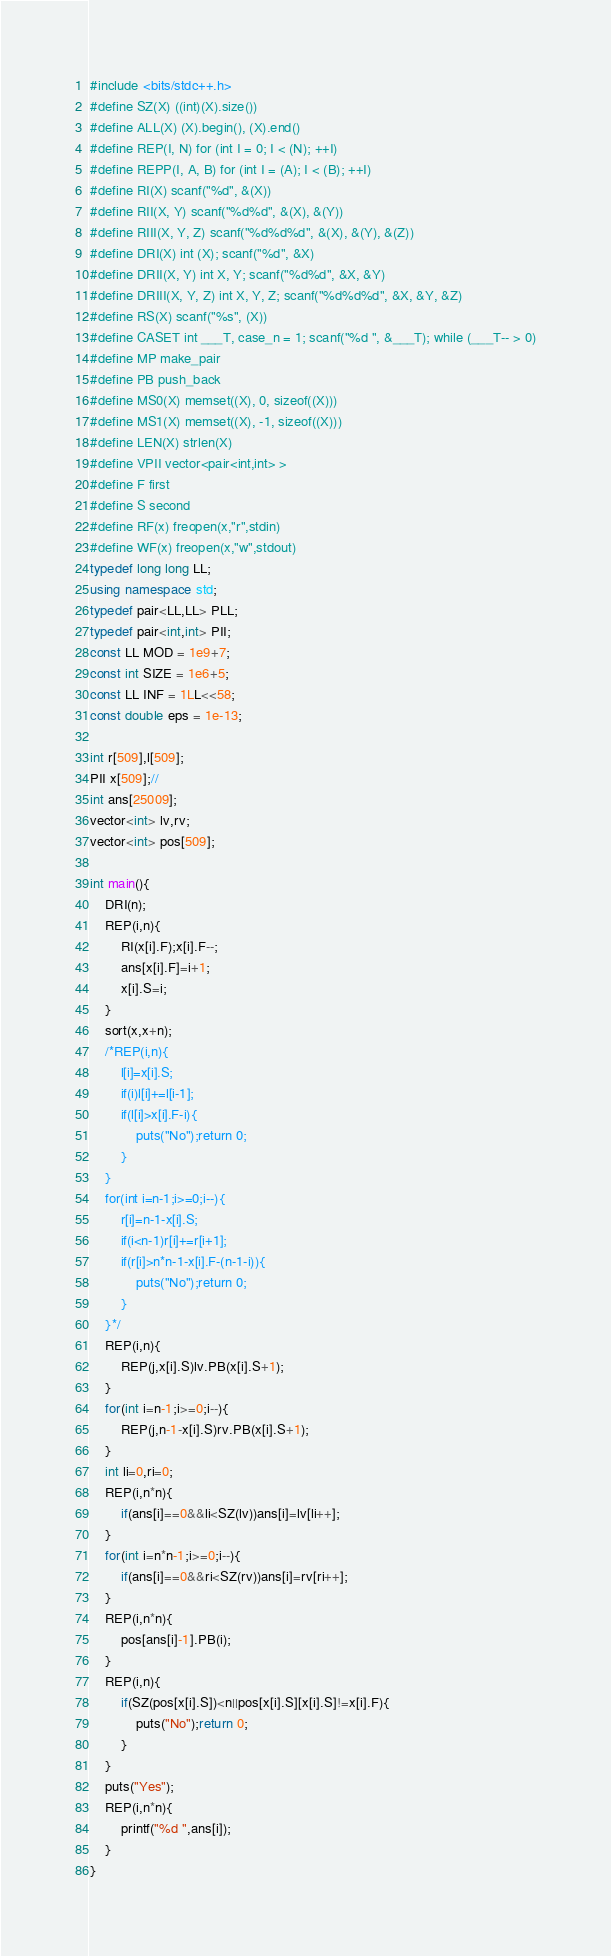<code> <loc_0><loc_0><loc_500><loc_500><_C++_>#include <bits/stdc++.h>
#define SZ(X) ((int)(X).size())
#define ALL(X) (X).begin(), (X).end()
#define REP(I, N) for (int I = 0; I < (N); ++I)
#define REPP(I, A, B) for (int I = (A); I < (B); ++I)
#define RI(X) scanf("%d", &(X))
#define RII(X, Y) scanf("%d%d", &(X), &(Y))
#define RIII(X, Y, Z) scanf("%d%d%d", &(X), &(Y), &(Z))
#define DRI(X) int (X); scanf("%d", &X)
#define DRII(X, Y) int X, Y; scanf("%d%d", &X, &Y)
#define DRIII(X, Y, Z) int X, Y, Z; scanf("%d%d%d", &X, &Y, &Z)
#define RS(X) scanf("%s", (X))
#define CASET int ___T, case_n = 1; scanf("%d ", &___T); while (___T-- > 0)
#define MP make_pair
#define PB push_back
#define MS0(X) memset((X), 0, sizeof((X)))
#define MS1(X) memset((X), -1, sizeof((X)))
#define LEN(X) strlen(X)
#define VPII vector<pair<int,int> >
#define F first
#define S second
#define RF(x) freopen(x,"r",stdin)
#define WF(x) freopen(x,"w",stdout)
typedef long long LL;
using namespace std;
typedef pair<LL,LL> PLL;
typedef pair<int,int> PII;
const LL MOD = 1e9+7;
const int SIZE = 1e6+5;
const LL INF = 1LL<<58;
const double eps = 1e-13;

int r[509],l[509];
PII x[509];//
int ans[25009];
vector<int> lv,rv;
vector<int> pos[509];

int main(){
	DRI(n);
	REP(i,n){
		RI(x[i].F);x[i].F--;
		ans[x[i].F]=i+1;
		x[i].S=i;
	}
	sort(x,x+n);
	/*REP(i,n){
		l[i]=x[i].S;
		if(i)l[i]+=l[i-1];
		if(l[i]>x[i].F-i){
			puts("No");return 0;
		}
	}
	for(int i=n-1;i>=0;i--){
		r[i]=n-1-x[i].S;
		if(i<n-1)r[i]+=r[i+1];
		if(r[i]>n*n-1-x[i].F-(n-1-i)){
			puts("No");return 0;
		}
	}*/
	REP(i,n){
		REP(j,x[i].S)lv.PB(x[i].S+1);
	}
	for(int i=n-1;i>=0;i--){
		REP(j,n-1-x[i].S)rv.PB(x[i].S+1);
	}
	int li=0,ri=0;
	REP(i,n*n){
		if(ans[i]==0&&li<SZ(lv))ans[i]=lv[li++];
	}
	for(int i=n*n-1;i>=0;i--){
		if(ans[i]==0&&ri<SZ(rv))ans[i]=rv[ri++];
	}
	REP(i,n*n){
		pos[ans[i]-1].PB(i);
	}
	REP(i,n){
		if(SZ(pos[x[i].S])<n||pos[x[i].S][x[i].S]!=x[i].F){
			puts("No");return 0;
		}
	}
	puts("Yes");
	REP(i,n*n){
		printf("%d ",ans[i]);
	}
}
</code> 